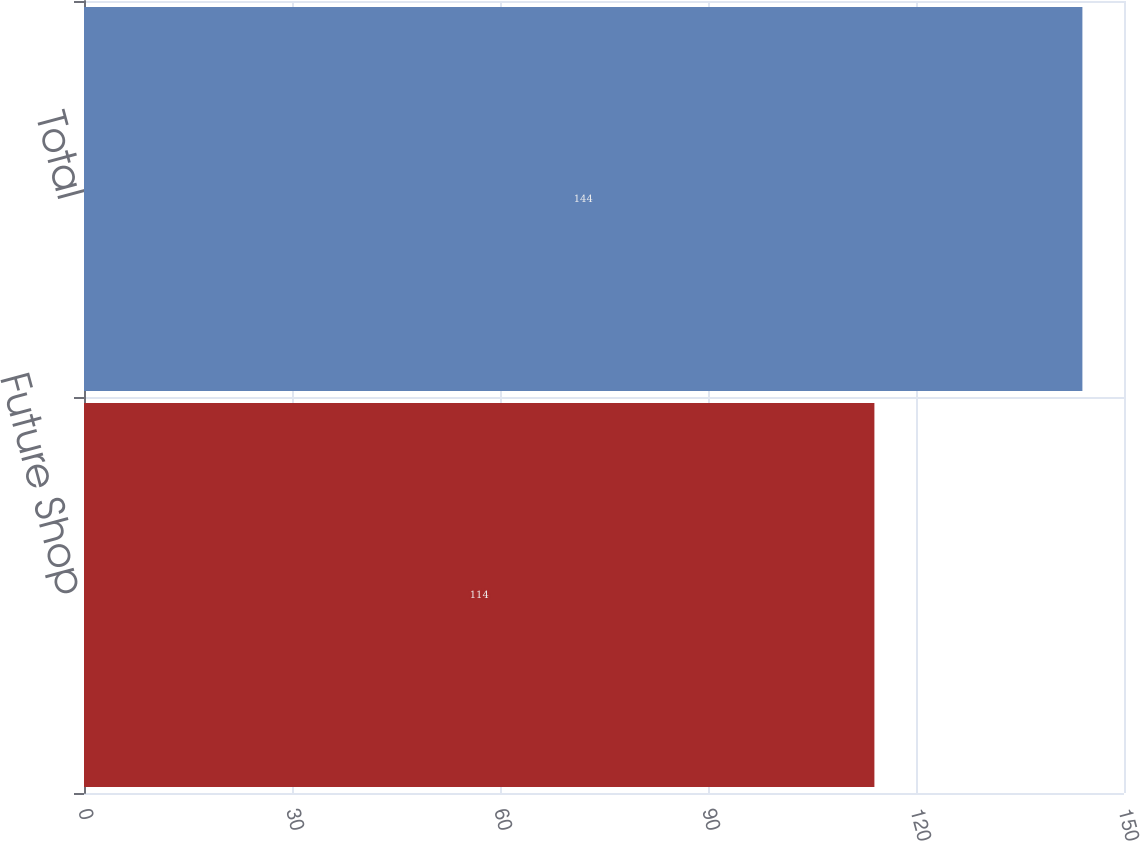<chart> <loc_0><loc_0><loc_500><loc_500><bar_chart><fcel>Future Shop<fcel>Total<nl><fcel>114<fcel>144<nl></chart> 